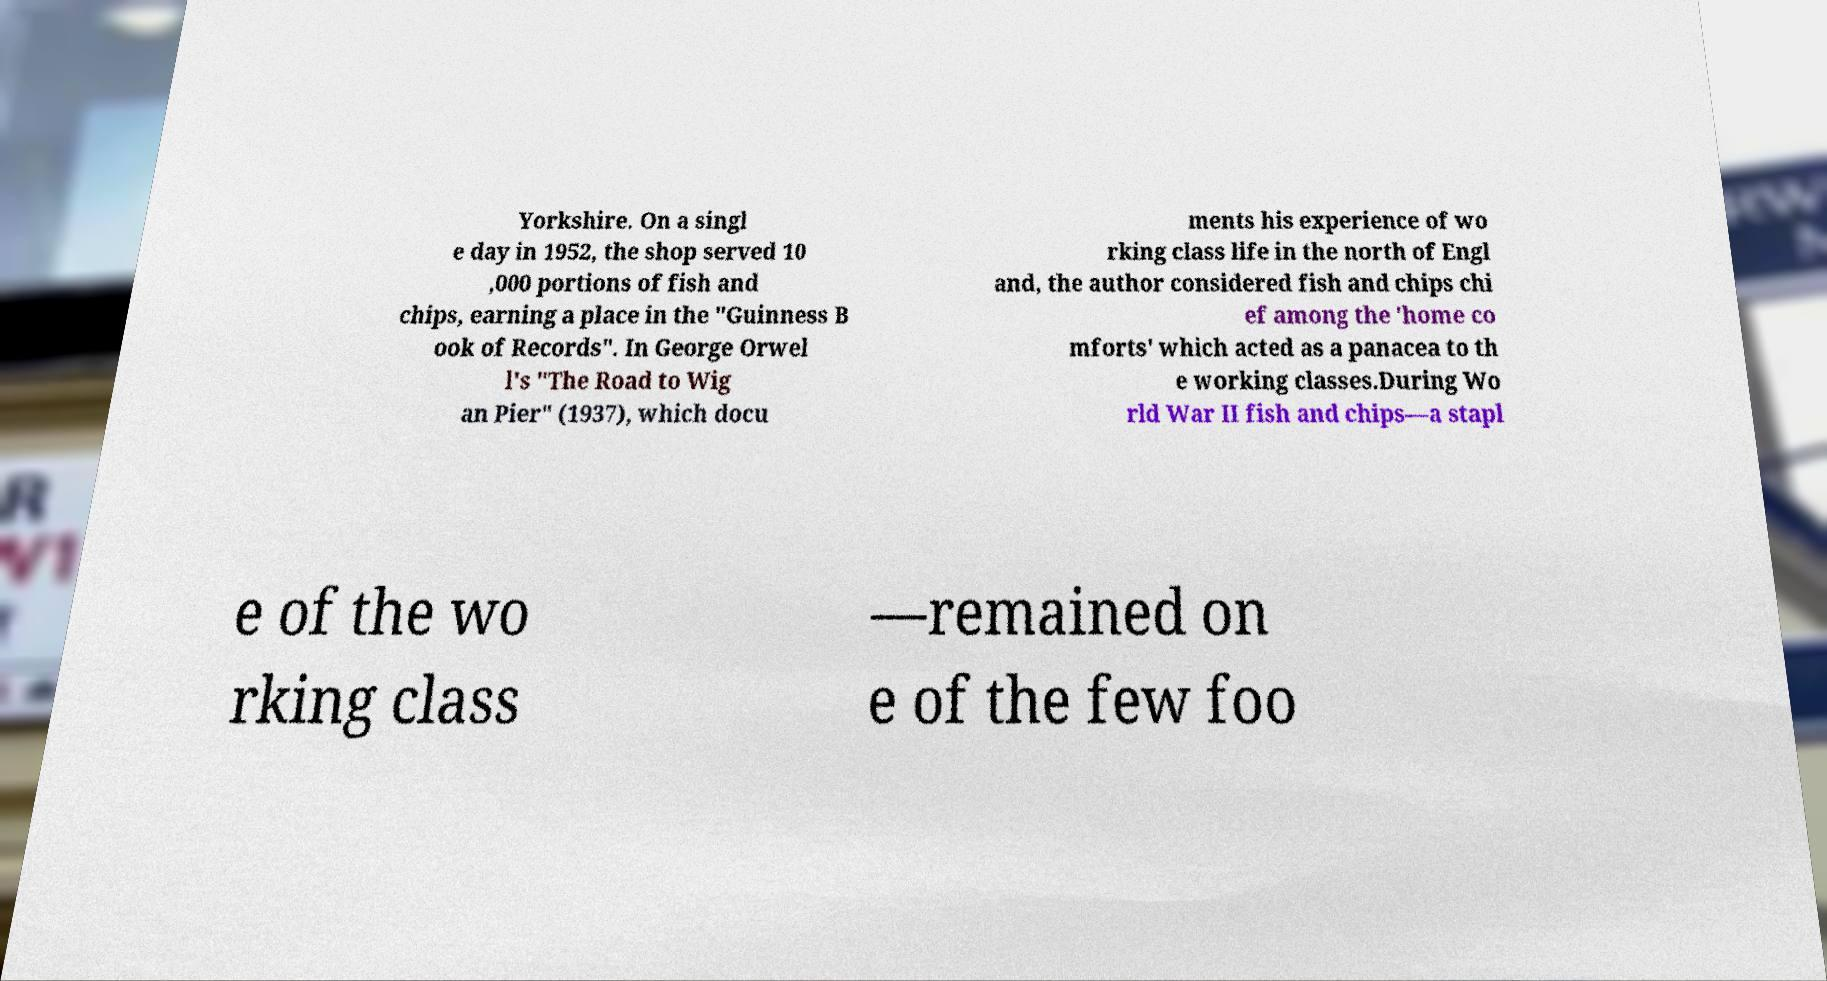Please identify and transcribe the text found in this image. Yorkshire. On a singl e day in 1952, the shop served 10 ,000 portions of fish and chips, earning a place in the "Guinness B ook of Records". In George Orwel l's "The Road to Wig an Pier" (1937), which docu ments his experience of wo rking class life in the north of Engl and, the author considered fish and chips chi ef among the 'home co mforts' which acted as a panacea to th e working classes.During Wo rld War II fish and chips—a stapl e of the wo rking class —remained on e of the few foo 